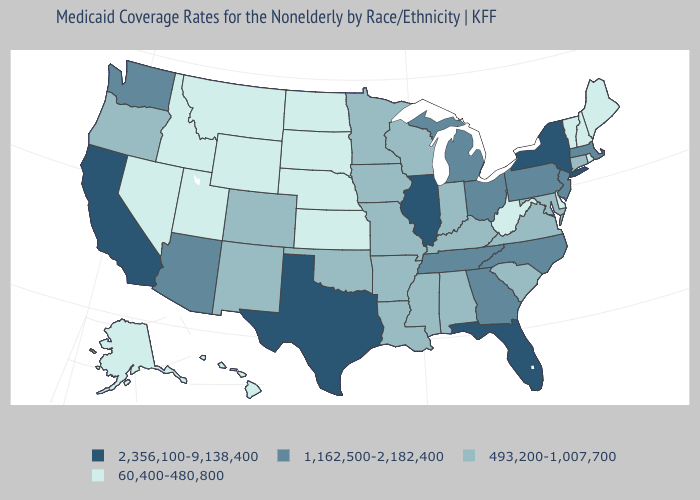Does Vermont have the lowest value in the USA?
Short answer required. Yes. What is the highest value in states that border North Dakota?
Short answer required. 493,200-1,007,700. How many symbols are there in the legend?
Write a very short answer. 4. Among the states that border California , does Nevada have the lowest value?
Keep it brief. Yes. What is the value of Texas?
Write a very short answer. 2,356,100-9,138,400. Name the states that have a value in the range 2,356,100-9,138,400?
Keep it brief. California, Florida, Illinois, New York, Texas. Does Wisconsin have the lowest value in the MidWest?
Answer briefly. No. Name the states that have a value in the range 60,400-480,800?
Write a very short answer. Alaska, Delaware, Hawaii, Idaho, Kansas, Maine, Montana, Nebraska, Nevada, New Hampshire, North Dakota, Rhode Island, South Dakota, Utah, Vermont, West Virginia, Wyoming. What is the value of North Dakota?
Give a very brief answer. 60,400-480,800. Does Vermont have the highest value in the USA?
Keep it brief. No. Among the states that border Illinois , which have the lowest value?
Answer briefly. Indiana, Iowa, Kentucky, Missouri, Wisconsin. What is the value of Colorado?
Keep it brief. 493,200-1,007,700. Name the states that have a value in the range 60,400-480,800?
Write a very short answer. Alaska, Delaware, Hawaii, Idaho, Kansas, Maine, Montana, Nebraska, Nevada, New Hampshire, North Dakota, Rhode Island, South Dakota, Utah, Vermont, West Virginia, Wyoming. What is the value of Vermont?
Keep it brief. 60,400-480,800. Which states have the lowest value in the USA?
Give a very brief answer. Alaska, Delaware, Hawaii, Idaho, Kansas, Maine, Montana, Nebraska, Nevada, New Hampshire, North Dakota, Rhode Island, South Dakota, Utah, Vermont, West Virginia, Wyoming. 